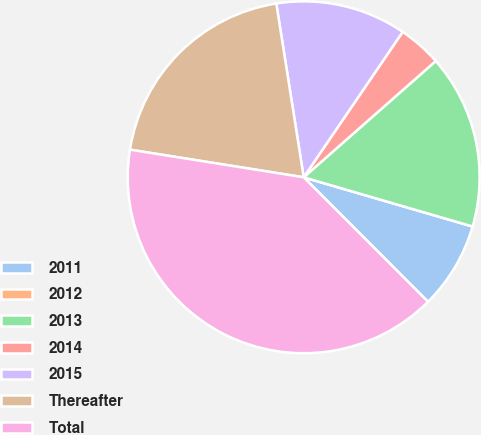Convert chart to OTSL. <chart><loc_0><loc_0><loc_500><loc_500><pie_chart><fcel>2011<fcel>2012<fcel>2013<fcel>2014<fcel>2015<fcel>Thereafter<fcel>Total<nl><fcel>8.0%<fcel>0.0%<fcel>16.0%<fcel>4.0%<fcel>12.0%<fcel>20.0%<fcel>40.0%<nl></chart> 